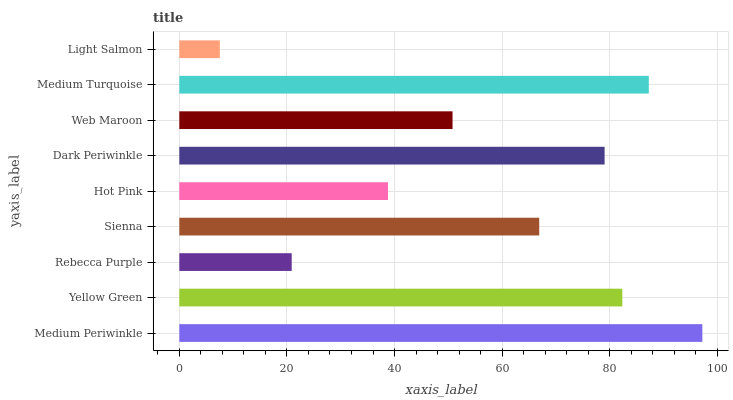Is Light Salmon the minimum?
Answer yes or no. Yes. Is Medium Periwinkle the maximum?
Answer yes or no. Yes. Is Yellow Green the minimum?
Answer yes or no. No. Is Yellow Green the maximum?
Answer yes or no. No. Is Medium Periwinkle greater than Yellow Green?
Answer yes or no. Yes. Is Yellow Green less than Medium Periwinkle?
Answer yes or no. Yes. Is Yellow Green greater than Medium Periwinkle?
Answer yes or no. No. Is Medium Periwinkle less than Yellow Green?
Answer yes or no. No. Is Sienna the high median?
Answer yes or no. Yes. Is Sienna the low median?
Answer yes or no. Yes. Is Light Salmon the high median?
Answer yes or no. No. Is Medium Periwinkle the low median?
Answer yes or no. No. 